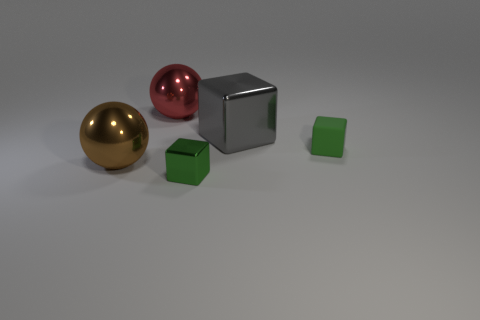Subtract all brown blocks. Subtract all yellow balls. How many blocks are left? 3 Add 1 gray rubber cylinders. How many objects exist? 6 Subtract all spheres. How many objects are left? 3 Add 5 large cubes. How many large cubes are left? 6 Add 5 small gray metal cylinders. How many small gray metal cylinders exist? 5 Subtract 1 red spheres. How many objects are left? 4 Subtract all large gray cubes. Subtract all brown objects. How many objects are left? 3 